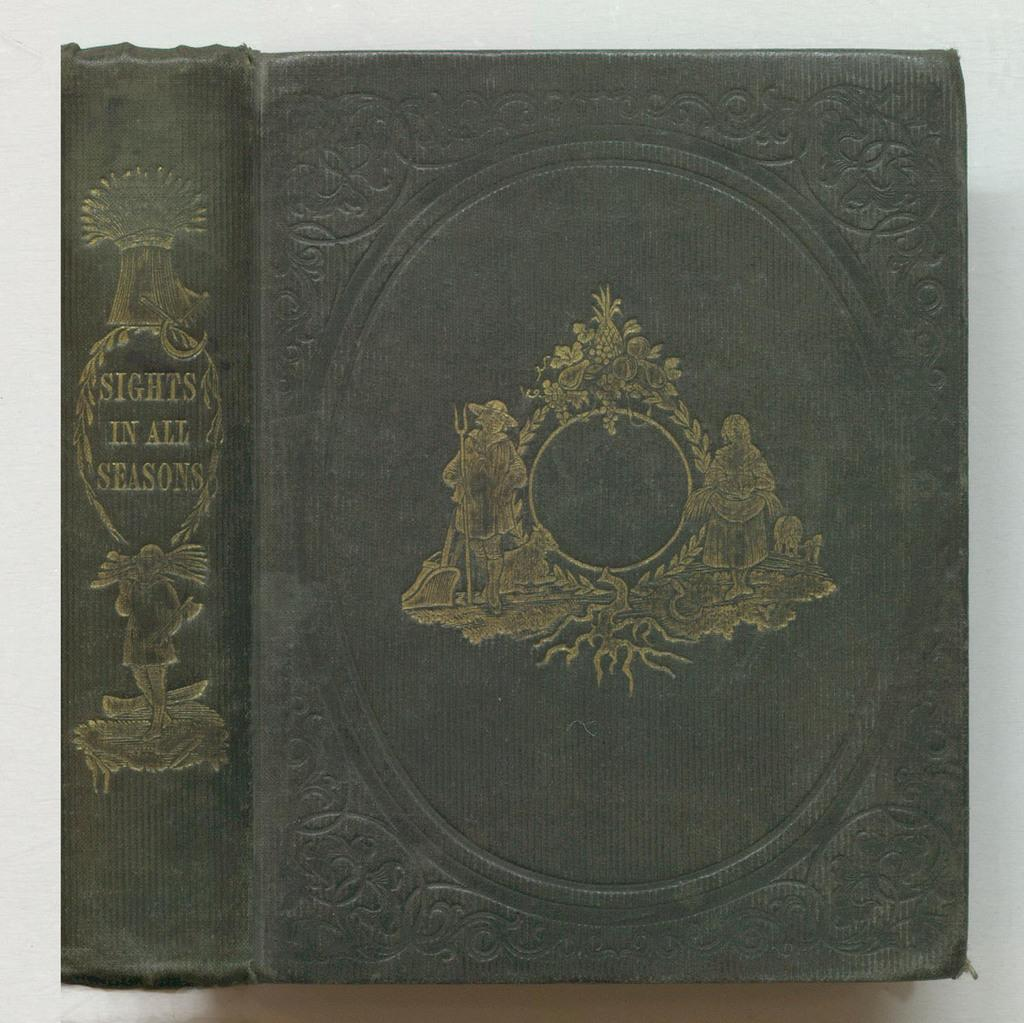<image>
Present a compact description of the photo's key features. A green hard covered book is titles Sights in all Seasons. 